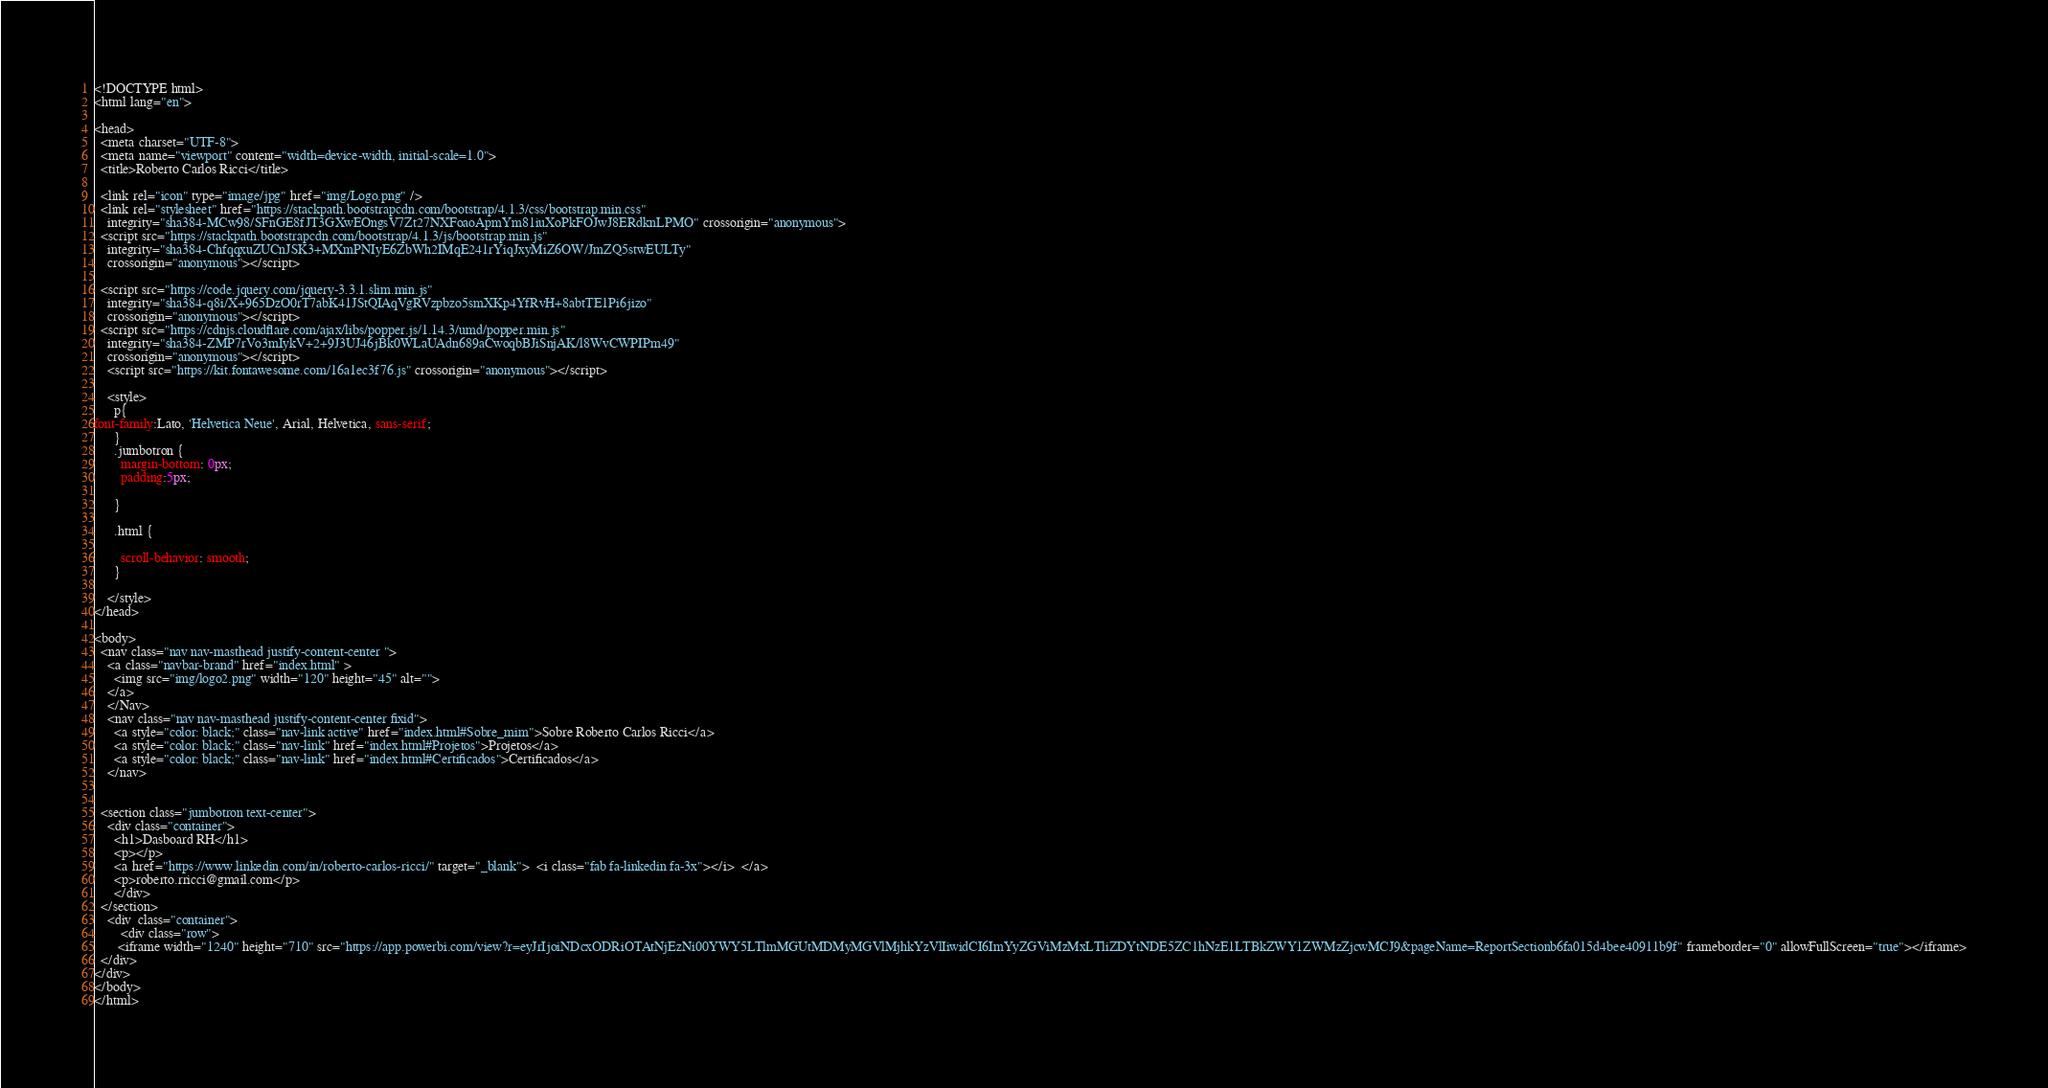<code> <loc_0><loc_0><loc_500><loc_500><_HTML_><!DOCTYPE html>
<html lang="en">

<head>
  <meta charset="UTF-8">
  <meta name="viewport" content="width=device-width, initial-scale=1.0">
  <title>Roberto Carlos Ricci</title>

  <link rel="icon" type="image/jpg" href="img/Logo.png" />
  <link rel="stylesheet" href="https://stackpath.bootstrapcdn.com/bootstrap/4.1.3/css/bootstrap.min.css"
    integrity="sha384-MCw98/SFnGE8fJT3GXwEOngsV7Zt27NXFoaoApmYm81iuXoPkFOJwJ8ERdknLPMO" crossorigin="anonymous">
  <script src="https://stackpath.bootstrapcdn.com/bootstrap/4.1.3/js/bootstrap.min.js"
    integrity="sha384-ChfqqxuZUCnJSK3+MXmPNIyE6ZbWh2IMqE241rYiqJxyMiZ6OW/JmZQ5stwEULTy"
    crossorigin="anonymous"></script>

  <script src="https://code.jquery.com/jquery-3.3.1.slim.min.js"
    integrity="sha384-q8i/X+965DzO0rT7abK41JStQIAqVgRVzpbzo5smXKp4YfRvH+8abtTE1Pi6jizo"
    crossorigin="anonymous"></script>
  <script src="https://cdnjs.cloudflare.com/ajax/libs/popper.js/1.14.3/umd/popper.min.js"
    integrity="sha384-ZMP7rVo3mIykV+2+9J3UJ46jBk0WLaUAdn689aCwoqbBJiSnjAK/l8WvCWPIPm49"
    crossorigin="anonymous"></script>
    <script src="https://kit.fontawesome.com/16a1ec3f76.js" crossorigin="anonymous"></script>

    <style>
      p{ 
font-family:Lato, 'Helvetica Neue', Arial, Helvetica, sans-serif;
      }
      .jumbotron {
        margin-bottom: 0px;
        padding:5px;

      }

      .html {

        scroll-behavior: smooth;
      }

    </style>
</head>

<body>
  <nav class="nav nav-masthead justify-content-center ">
    <a class="navbar-brand" href="index.html" >
      <img src="img/logo2.png" width="120" height="45" alt="">
    </a>
    </Nav>
    <nav class="nav nav-masthead justify-content-center fixid">
      <a style="color: black;" class="nav-link active" href="index.html#Sobre_mim">Sobre Roberto Carlos Ricci</a>
      <a style="color: black;" class="nav-link" href="index.html#Projetos">Projetos</a>
      <a style="color: black;" class="nav-link" href="index.html#Certificados">Certificados</a>
    </nav>
 

  <section class="jumbotron text-center">
    <div class="container">
      <h1>Dasboard RH</h1>
      <p></p>
      <a href="https://www.linkedin.com/in/roberto-carlos-ricci/" target="_blank">  <i class="fab fa-linkedin fa-3x"></i>  </a>
      <p>roberto.rricci@gmail.com</p>
      </div>
  </section>
    <div  class="container">
        <div class="row">
       <iframe width="1240" height="710" src="https://app.powerbi.com/view?r=eyJrIjoiNDcxODRiOTAtNjEzNi00YWY5LTlmMGUtMDMyMGVlMjhkYzVlIiwidCI6ImYyZGViMzMxLTliZDYtNDE5ZC1hNzE1LTBkZWY1ZWMzZjcwMCJ9&pageName=ReportSectionb6fa015d4bee40911b9f" frameborder="0" allowFullScreen="true"></iframe>
  </div>
</div>
</body>
</html></code> 